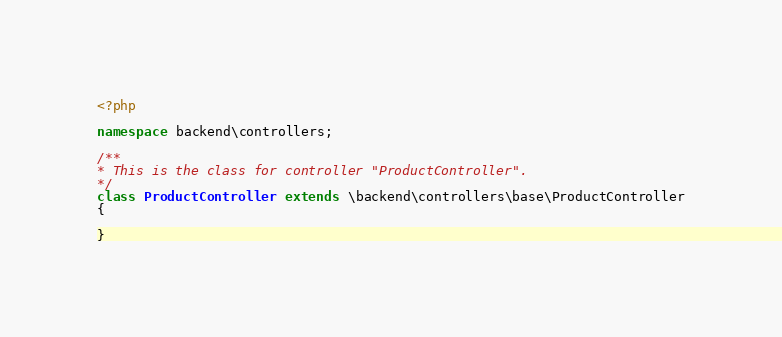Convert code to text. <code><loc_0><loc_0><loc_500><loc_500><_PHP_><?php

namespace backend\controllers;

/**
* This is the class for controller "ProductController".
*/
class ProductController extends \backend\controllers\base\ProductController
{

}
</code> 